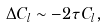Convert formula to latex. <formula><loc_0><loc_0><loc_500><loc_500>\Delta C _ { l } \sim - 2 \tau C _ { l } ,</formula> 